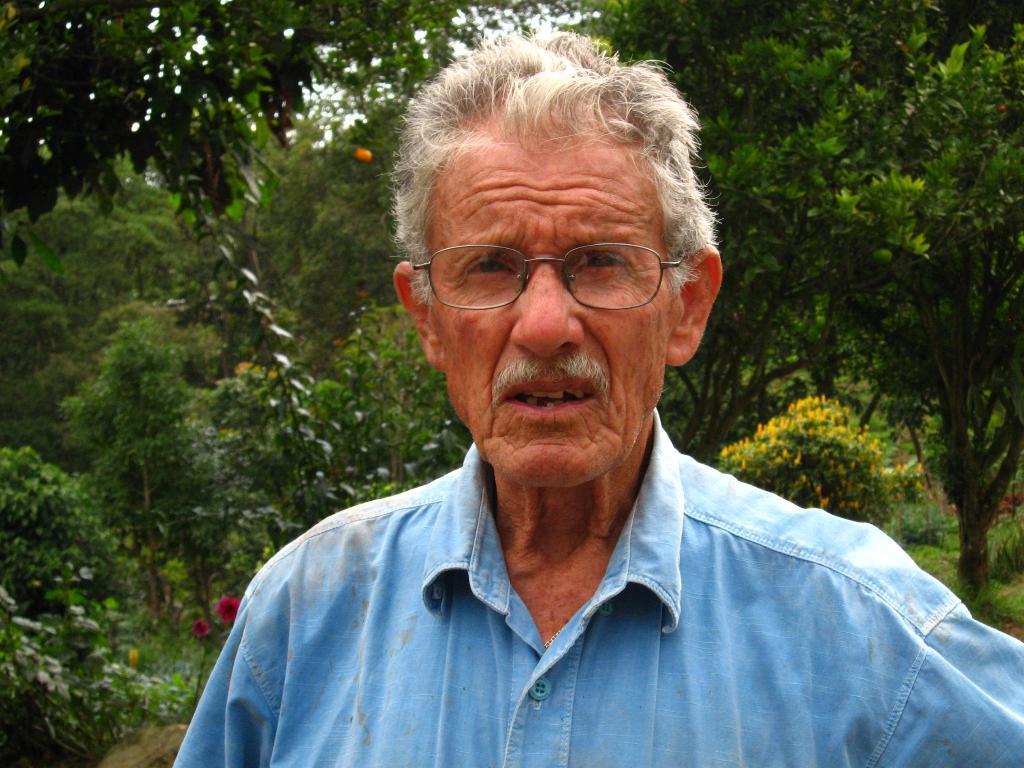Describe this image in one or two sentences. In this picture we can see a person. There are few flowers and plants in the background. 